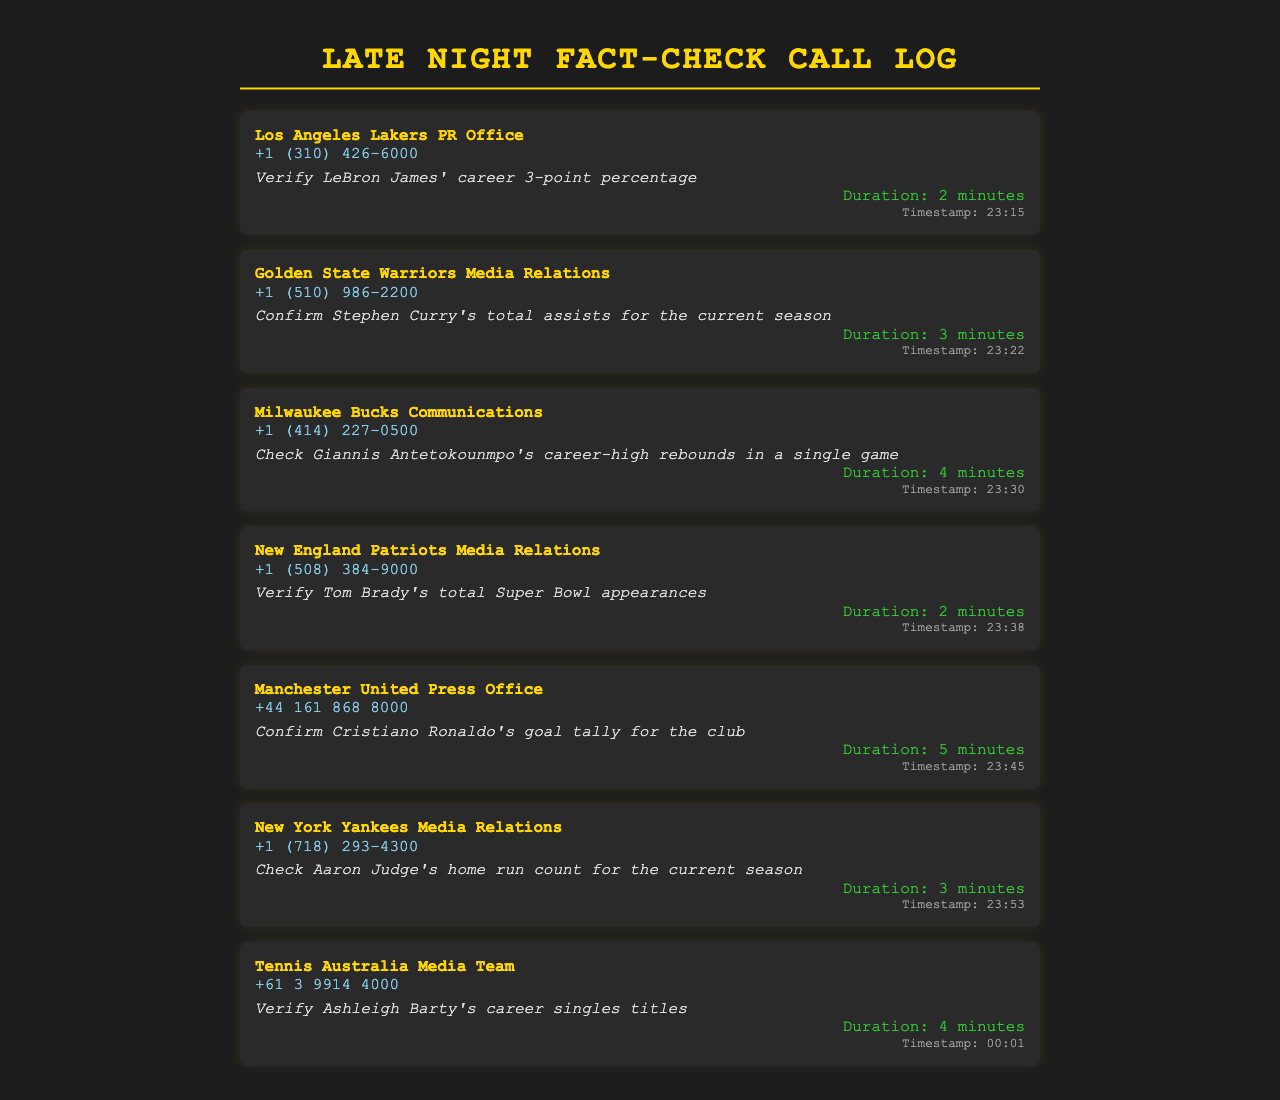What is the purpose of the call to the Los Angeles Lakers PR Office? The purpose of the call is to verify LeBron James' career 3-point percentage.
Answer: Verify LeBron James' career 3-point percentage What is the timestamp for the call made to the Milwaukee Bucks Communications? The timestamp indicates when the call was made to the Milwaukee Bucks Communications. The call was made at 23:30.
Answer: 23:30 How long was the call to the New England Patriots Media Relations? The duration of the call to the New England Patriots Media Relations is stated in the document. It lasted for 2 minutes.
Answer: 2 minutes Which team press office was contacted to confirm Cristiano Ronaldo's goal tally? The document specifies the contact for confirming Cristiano Ronaldo's goal tally, which is the Manchester United Press Office.
Answer: Manchester United Press Office How many total assists is the editor confirming with the Golden State Warriors Media Relations? The document describes the confirmation of Stephen Curry's total assists for the current season.
Answer: Stephen Curry's total assists for the current season What contact number was used to call the New York Yankees Media Relations? The document provides the contact number that was called for the New York Yankees Media Relations.
Answer: +1 (718) 293-4300 Which player’s career singles titles are being verified by the Tennis Australia Media Team? The document indicates that the call was made to verify Ashleigh Barty's career singles titles.
Answer: Ashleigh Barty What is the total number of calls logged in this document? Summing the individual calls listed in the document, there are a total of 7 calls logged.
Answer: 7 calls What is the duration of the call to confirm Aaron Judge's home run count? The duration of the call is included in the log for the New York Yankees Media Relations. It lasted for 3 minutes.
Answer: 3 minutes 